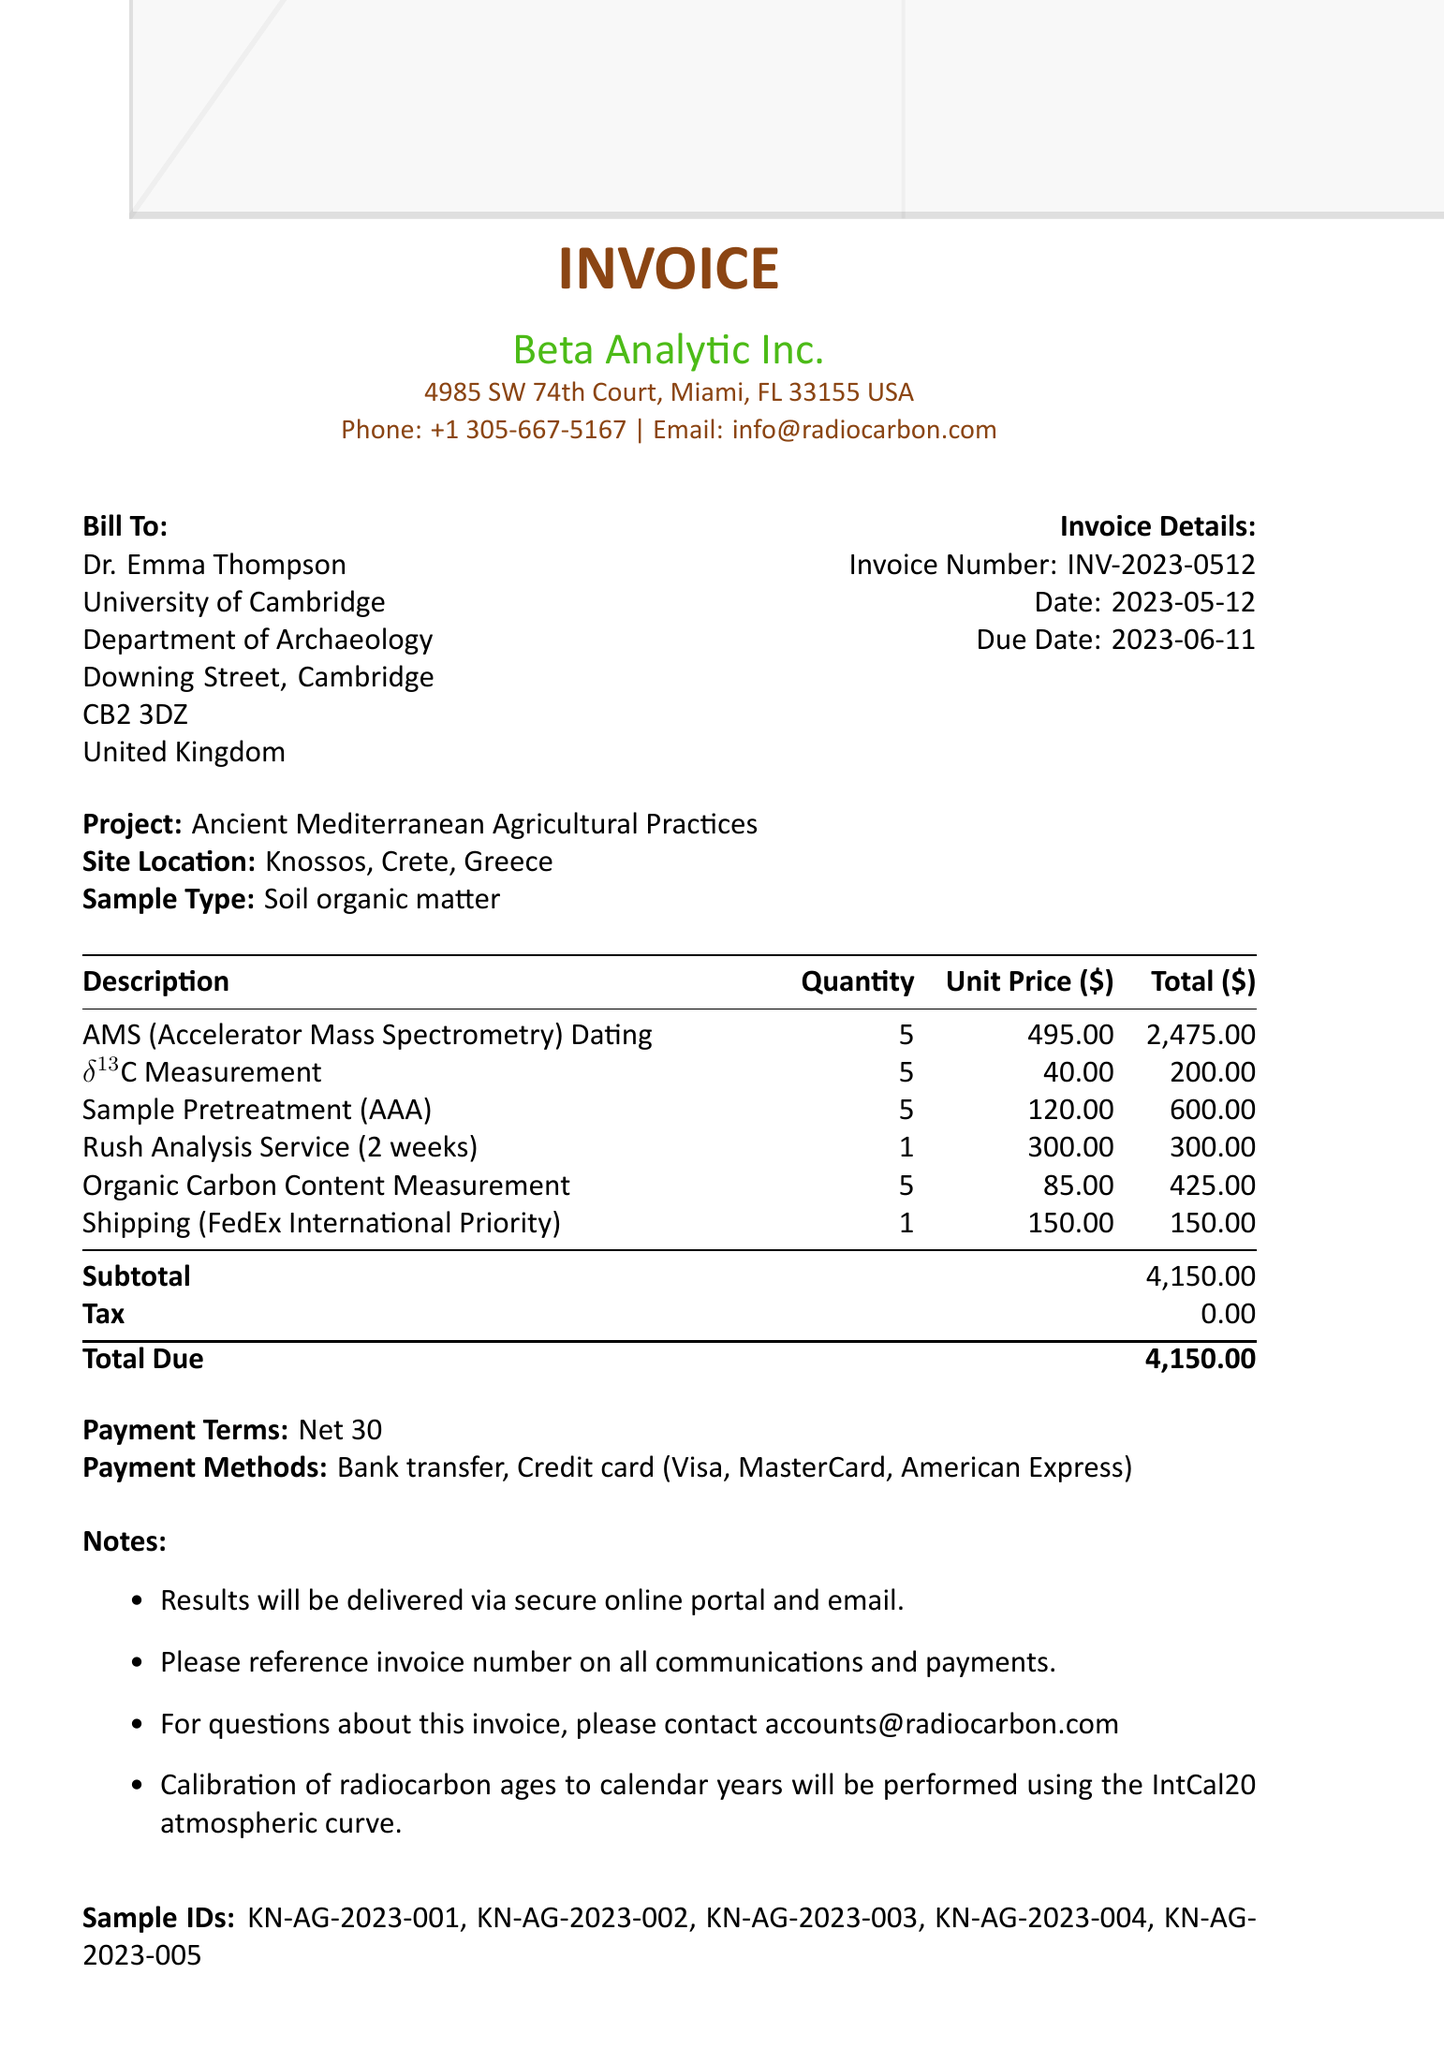What is the invoice number? The invoice number is a unique identifier for the invoice document, specified in the details of the invoice.
Answer: INV-2023-0512 Who is the client? The client is the person or entity receiving the services, mentioned in the 'Bill To' section of the invoice.
Answer: Dr. Emma Thompson What is the due date for the payment? The due date indicates when the payment should be made, specified clearly within the invoice.
Answer: 2023-06-11 What type of dating service is provided? The description of the services offered includes specific methodologies, which are detailed in the services section.
Answer: AMS (Accelerator Mass Spectrometry) Dating What is the subtotal amount? The subtotal is the total cost before tax and is listed towards the end of the invoice.
Answer: 4150.00 How many soil samples were analyzed? The quantity of soil samples processed is indicated alongside the descriptions of the services provided in the invoice.
Answer: 5 What is the shipping method used? The shipping method indicates how the samples were sent and is specified under the shipping section of the invoice.
Answer: FedEx International Priority What payment methods are accepted? The payment methods indicate how the client can make the payment for the services rendered, as listed in the invoice.
Answer: Bank transfer, Credit card (Visa, MasterCard, American Express) What is the calibration information provided? The calibration information relates to how the radiocarbon ages will be adjusted and is specified at the end of the invoice.
Answer: Calibration of radiocarbon ages to calendar years will be performed using the IntCal20 atmospheric curve 